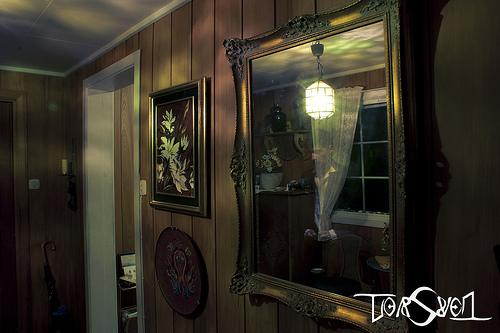What is the overall sentiment or mood conveyed by this image? The overall sentiment of the image is warm, cozy, and inviting due to the wooden panel walls and decorative objects. Give a brief overview of the room's content and atmosphere. The room features a large brass mirror, framed picture, round ceramic plate, candle rack, light switch, and an umbrella. It has a cozy atmosphere with wooden panels and warm lighting. How many objects could you count leaning or hanging on the wall, and what color is the wall made of? There are 12 objects hanging or leaning on the wall, and the wall is made of brown wooden panels. Identify a unique feature of the mirror, and provide a reasoning task based on it. The mirror is made of brass, which makes it a statement piece in the room. A reasoning task could be determining what other decor pieces would complement the mirror in terms of materials or colors. What type of interaction is observed between the objects in the image? The interaction between objects is primarily reflective, such as the mirror displaying several distinct reflections like curtains, chandelier, and potted plant. Estimate how many distinct reflections can be seen in the brass mirror. There are at least seven distinct reflections visible in the brass mirror. Look for the bouquet of flowers placed on top of a wooden cabinet on the wall. Don't you think it adds a refreshing touch to the room? This instruction is misleading because there is no mention of a bouquet of flowers or a wooden cabinet in the given object captions. The declarative sentence creates an illusion of the objects, and the interrogative sentence guides the reader into imagining how they might impact the room's ambiance. Can you see the frameless painting of a beach scene next to the doorway? It's so calming and inviting. This instruction is misleading because there is no mention of a frameless painting of a beach scene in the given object captions. The interrogative sentence encourages the reader to attempt to find a nonexistent object, while the declarative sentence creates an illusion of its existence. Observe the large, green potted plant near the umbrella leaning against the wall. Doesn't it bring a bit of life into the room? This instruction is misleading because there is no mention of a large, green potted plant in the given object captions. The interrogative sentence prompts the reader to try to find the non-existent object, while the declarative sentence portrays it as an essential element to the room's atmosphere. Did you notice the framed black-and-white photograph of a vintage car hanging on the wall? The contrast with the wooden panels is striking. This instruction is misleading because there is no mention of a framed black-and-white photograph in the given object captions. The interrogative sentence prompts the reader to consider finding the nonexistent object, while the declarative sentence creates a visual of its appearance and significance. Pay attention to the colorful, abstract rug on the floor by the door. Do you think it adds warmth and character to the space? This instruction is misleading because there is no mention of a colorful, abstract rug in the given object captions. The interrogative sentence encourages the reader to assess an object that doesn't exist, while the declarative sentence creates a sense of its impact on the room's overall design. Try to spot the small statuette of a dancing couple on the shelf reflected in the mirror. It's a lovely piece of artwork, isn't it? This instruction is misleading because there is no mention of a small statuette in the given object captions. The interrogative sentence asks the reader to find something that's not there, while the declarative sentence creates a mental image of the non-existent object. 